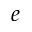<formula> <loc_0><loc_0><loc_500><loc_500>e</formula> 